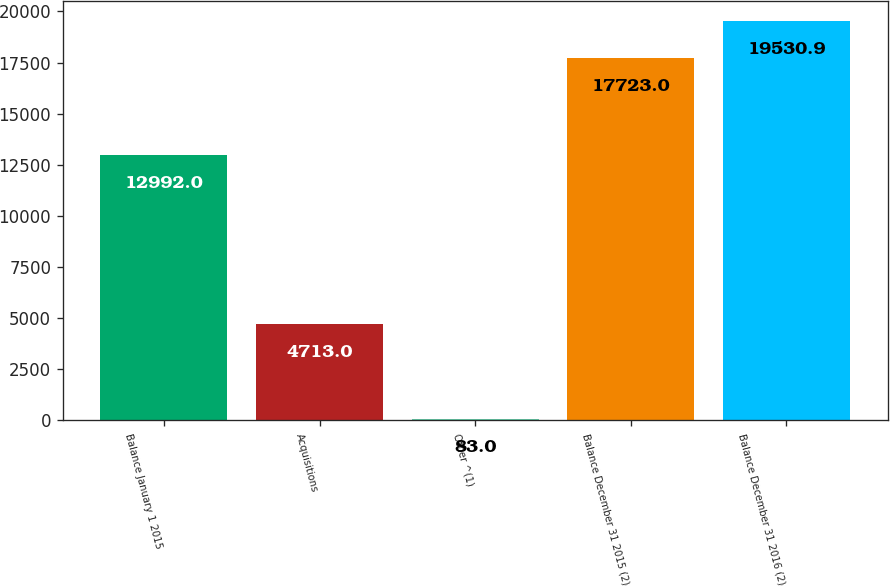Convert chart. <chart><loc_0><loc_0><loc_500><loc_500><bar_chart><fcel>Balance January 1 2015<fcel>Acquisitions<fcel>Other ^(1)<fcel>Balance December 31 2015 (2)<fcel>Balance December 31 2016 (2)<nl><fcel>12992<fcel>4713<fcel>83<fcel>17723<fcel>19530.9<nl></chart> 